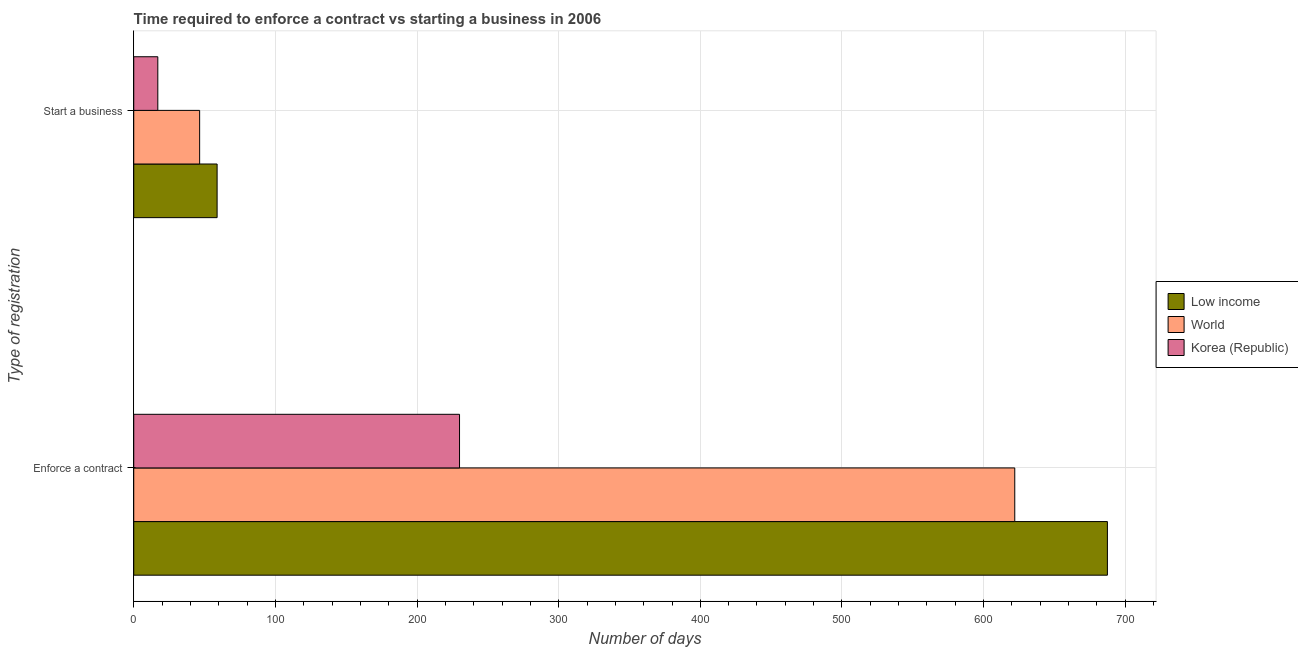How many different coloured bars are there?
Provide a short and direct response. 3. How many groups of bars are there?
Give a very brief answer. 2. How many bars are there on the 1st tick from the top?
Make the answer very short. 3. How many bars are there on the 2nd tick from the bottom?
Keep it short and to the point. 3. What is the label of the 2nd group of bars from the top?
Offer a terse response. Enforce a contract. What is the number of days to enforece a contract in Low income?
Offer a very short reply. 687.39. Across all countries, what is the maximum number of days to enforece a contract?
Ensure brevity in your answer.  687.39. Across all countries, what is the minimum number of days to start a business?
Make the answer very short. 17. In which country was the number of days to start a business maximum?
Give a very brief answer. Low income. In which country was the number of days to enforece a contract minimum?
Your response must be concise. Korea (Republic). What is the total number of days to start a business in the graph?
Keep it short and to the point. 122.39. What is the difference between the number of days to enforece a contract in World and that in Low income?
Your response must be concise. -65.4. What is the difference between the number of days to start a business in Low income and the number of days to enforece a contract in Korea (Republic)?
Provide a short and direct response. -171.14. What is the average number of days to start a business per country?
Ensure brevity in your answer.  40.8. What is the difference between the number of days to enforece a contract and number of days to start a business in Low income?
Provide a succinct answer. 628.54. In how many countries, is the number of days to enforece a contract greater than 160 days?
Your response must be concise. 3. What is the ratio of the number of days to enforece a contract in Korea (Republic) to that in Low income?
Offer a very short reply. 0.33. Is the number of days to enforece a contract in Korea (Republic) less than that in World?
Keep it short and to the point. Yes. What does the 2nd bar from the top in Start a business represents?
Offer a terse response. World. How many countries are there in the graph?
Provide a succinct answer. 3. What is the difference between two consecutive major ticks on the X-axis?
Keep it short and to the point. 100. Are the values on the major ticks of X-axis written in scientific E-notation?
Your answer should be very brief. No. Does the graph contain any zero values?
Provide a succinct answer. No. Does the graph contain grids?
Keep it short and to the point. Yes. Where does the legend appear in the graph?
Make the answer very short. Center right. How are the legend labels stacked?
Keep it short and to the point. Vertical. What is the title of the graph?
Your answer should be compact. Time required to enforce a contract vs starting a business in 2006. What is the label or title of the X-axis?
Your answer should be compact. Number of days. What is the label or title of the Y-axis?
Provide a short and direct response. Type of registration. What is the Number of days in Low income in Enforce a contract?
Provide a short and direct response. 687.39. What is the Number of days in World in Enforce a contract?
Your answer should be compact. 621.99. What is the Number of days in Korea (Republic) in Enforce a contract?
Provide a short and direct response. 230. What is the Number of days in Low income in Start a business?
Offer a terse response. 58.86. What is the Number of days of World in Start a business?
Ensure brevity in your answer.  46.53. Across all Type of registration, what is the maximum Number of days in Low income?
Give a very brief answer. 687.39. Across all Type of registration, what is the maximum Number of days of World?
Keep it short and to the point. 621.99. Across all Type of registration, what is the maximum Number of days in Korea (Republic)?
Your response must be concise. 230. Across all Type of registration, what is the minimum Number of days of Low income?
Make the answer very short. 58.86. Across all Type of registration, what is the minimum Number of days in World?
Offer a terse response. 46.53. Across all Type of registration, what is the minimum Number of days of Korea (Republic)?
Give a very brief answer. 17. What is the total Number of days of Low income in the graph?
Your answer should be compact. 746.25. What is the total Number of days of World in the graph?
Provide a short and direct response. 668.52. What is the total Number of days in Korea (Republic) in the graph?
Provide a short and direct response. 247. What is the difference between the Number of days in Low income in Enforce a contract and that in Start a business?
Give a very brief answer. 628.54. What is the difference between the Number of days in World in Enforce a contract and that in Start a business?
Give a very brief answer. 575.46. What is the difference between the Number of days in Korea (Republic) in Enforce a contract and that in Start a business?
Give a very brief answer. 213. What is the difference between the Number of days in Low income in Enforce a contract and the Number of days in World in Start a business?
Give a very brief answer. 640.86. What is the difference between the Number of days of Low income in Enforce a contract and the Number of days of Korea (Republic) in Start a business?
Offer a very short reply. 670.39. What is the difference between the Number of days in World in Enforce a contract and the Number of days in Korea (Republic) in Start a business?
Provide a succinct answer. 604.99. What is the average Number of days of Low income per Type of registration?
Offer a very short reply. 373.12. What is the average Number of days in World per Type of registration?
Your answer should be compact. 334.26. What is the average Number of days of Korea (Republic) per Type of registration?
Make the answer very short. 123.5. What is the difference between the Number of days of Low income and Number of days of World in Enforce a contract?
Your response must be concise. 65.4. What is the difference between the Number of days of Low income and Number of days of Korea (Republic) in Enforce a contract?
Give a very brief answer. 457.39. What is the difference between the Number of days of World and Number of days of Korea (Republic) in Enforce a contract?
Ensure brevity in your answer.  391.99. What is the difference between the Number of days of Low income and Number of days of World in Start a business?
Provide a short and direct response. 12.33. What is the difference between the Number of days of Low income and Number of days of Korea (Republic) in Start a business?
Your answer should be very brief. 41.86. What is the difference between the Number of days of World and Number of days of Korea (Republic) in Start a business?
Your response must be concise. 29.53. What is the ratio of the Number of days of Low income in Enforce a contract to that in Start a business?
Ensure brevity in your answer.  11.68. What is the ratio of the Number of days in World in Enforce a contract to that in Start a business?
Provide a succinct answer. 13.37. What is the ratio of the Number of days in Korea (Republic) in Enforce a contract to that in Start a business?
Your response must be concise. 13.53. What is the difference between the highest and the second highest Number of days in Low income?
Your answer should be compact. 628.54. What is the difference between the highest and the second highest Number of days in World?
Provide a short and direct response. 575.46. What is the difference between the highest and the second highest Number of days in Korea (Republic)?
Your answer should be compact. 213. What is the difference between the highest and the lowest Number of days in Low income?
Your response must be concise. 628.54. What is the difference between the highest and the lowest Number of days in World?
Your response must be concise. 575.46. What is the difference between the highest and the lowest Number of days in Korea (Republic)?
Ensure brevity in your answer.  213. 